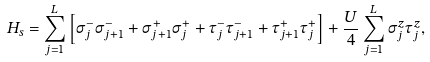<formula> <loc_0><loc_0><loc_500><loc_500>H _ { s } = \sum _ { j = 1 } ^ { L } \left [ \sigma ^ { - } _ { j } \sigma ^ { - } _ { j + 1 } + \sigma ^ { + } _ { j + 1 } \sigma ^ { + } _ { j } + \tau ^ { - } _ { j } \tau ^ { - } _ { j + 1 } + \tau ^ { + } _ { j + 1 } \tau ^ { + } _ { j } \right ] + \frac { U } { 4 } \sum _ { j = 1 } ^ { L } \sigma ^ { z } _ { j } \tau ^ { z } _ { j } ,</formula> 